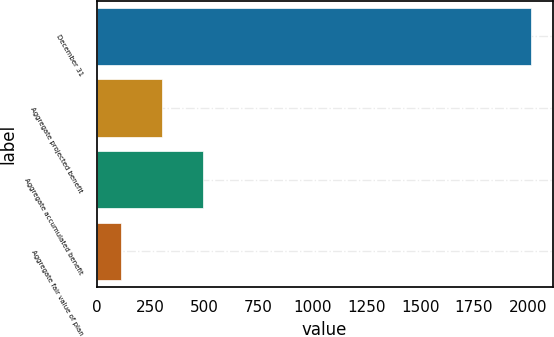Convert chart. <chart><loc_0><loc_0><loc_500><loc_500><bar_chart><fcel>December 31<fcel>Aggregate projected benefit<fcel>Aggregate accumulated benefit<fcel>Aggregate fair value of plan<nl><fcel>2014<fcel>301.75<fcel>492<fcel>111.5<nl></chart> 